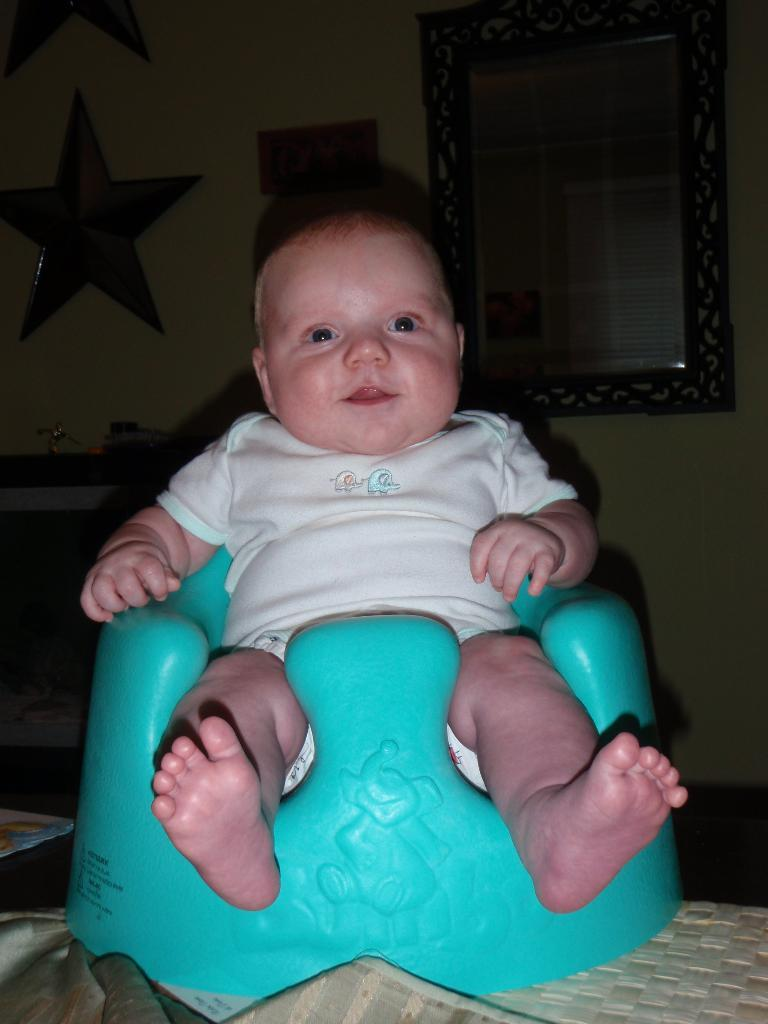What is the main subject of the image? There is a small kid in the image. What is the kid doing in the image? The kid is sitting in a chair. Can you describe the chair the kid is sitting on? The chair is blue. What can be seen in the background of the image? There is a wall in the background of the image. What is fixed on the wall in the background? There is a mirror fixed on the wall in the background. How does the kid change their body position while sitting in the chair? The image does not show the kid changing their body position; they are simply sitting in the chair. 